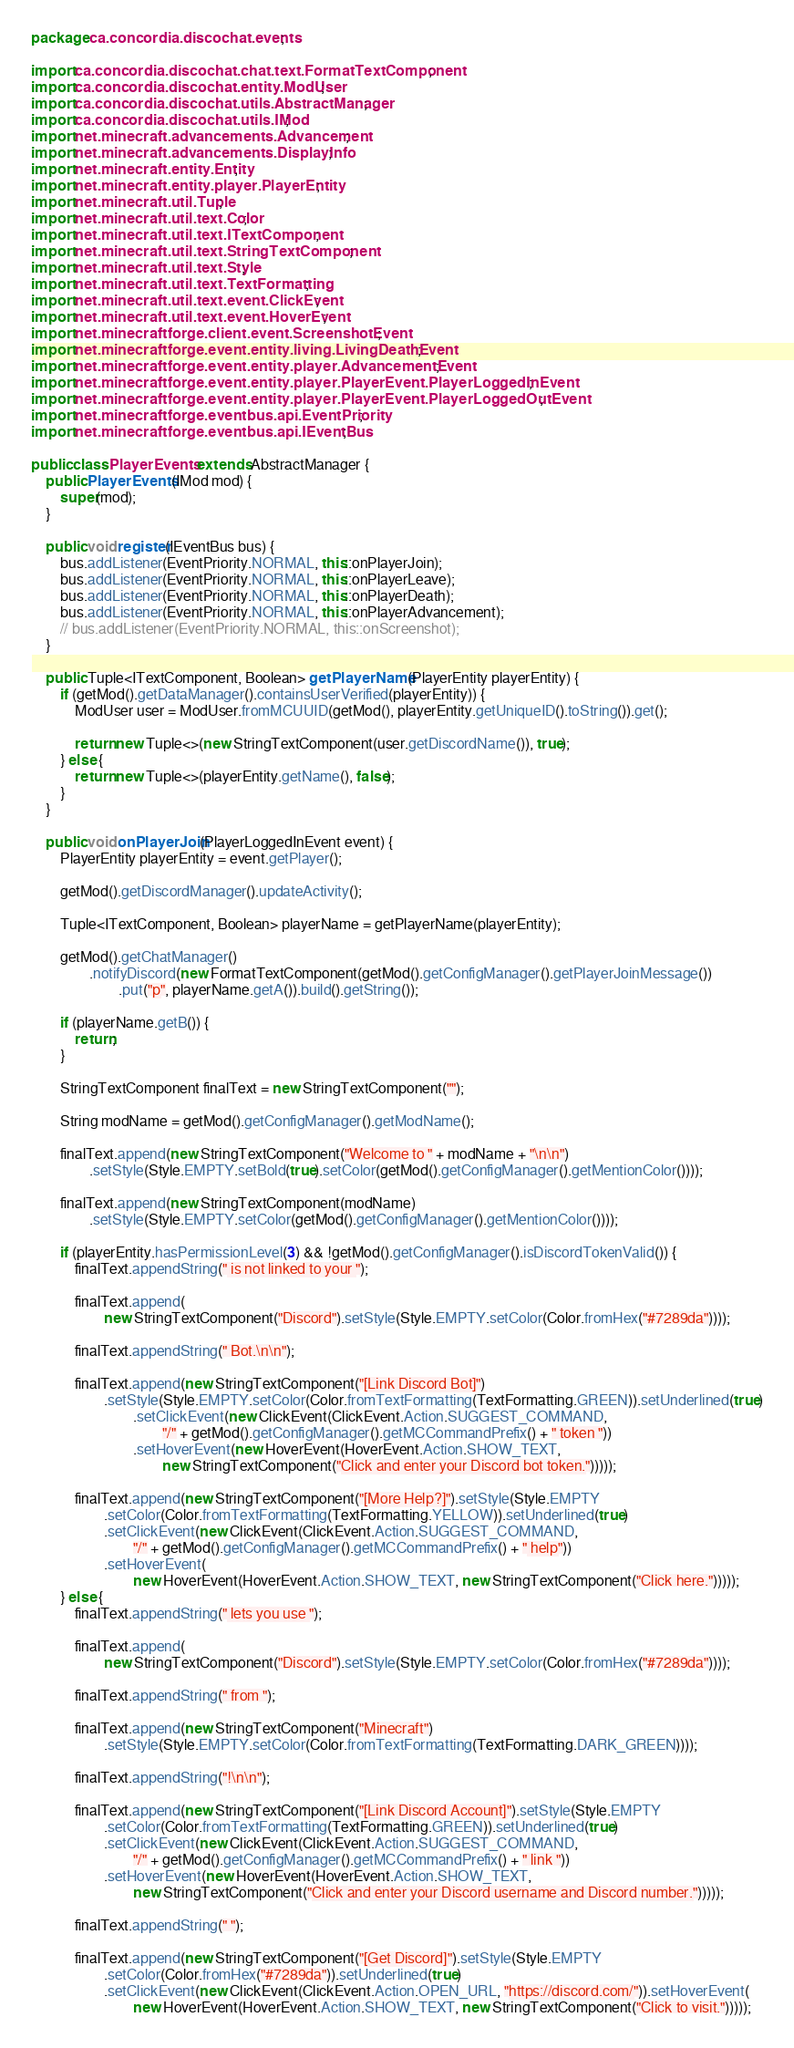<code> <loc_0><loc_0><loc_500><loc_500><_Java_>package ca.concordia.discochat.events;

import ca.concordia.discochat.chat.text.FormatTextComponent;
import ca.concordia.discochat.entity.ModUser;
import ca.concordia.discochat.utils.AbstractManager;
import ca.concordia.discochat.utils.IMod;
import net.minecraft.advancements.Advancement;
import net.minecraft.advancements.DisplayInfo;
import net.minecraft.entity.Entity;
import net.minecraft.entity.player.PlayerEntity;
import net.minecraft.util.Tuple;
import net.minecraft.util.text.Color;
import net.minecraft.util.text.ITextComponent;
import net.minecraft.util.text.StringTextComponent;
import net.minecraft.util.text.Style;
import net.minecraft.util.text.TextFormatting;
import net.minecraft.util.text.event.ClickEvent;
import net.minecraft.util.text.event.HoverEvent;
import net.minecraftforge.client.event.ScreenshotEvent;
import net.minecraftforge.event.entity.living.LivingDeathEvent;
import net.minecraftforge.event.entity.player.AdvancementEvent;
import net.minecraftforge.event.entity.player.PlayerEvent.PlayerLoggedInEvent;
import net.minecraftforge.event.entity.player.PlayerEvent.PlayerLoggedOutEvent;
import net.minecraftforge.eventbus.api.EventPriority;
import net.minecraftforge.eventbus.api.IEventBus;

public class PlayerEvents extends AbstractManager {
    public PlayerEvents(IMod mod) {
        super(mod);
    }

    public void register(IEventBus bus) {
        bus.addListener(EventPriority.NORMAL, this::onPlayerJoin);
        bus.addListener(EventPriority.NORMAL, this::onPlayerLeave);
        bus.addListener(EventPriority.NORMAL, this::onPlayerDeath);
        bus.addListener(EventPriority.NORMAL, this::onPlayerAdvancement);
        // bus.addListener(EventPriority.NORMAL, this::onScreenshot);
    }

    public Tuple<ITextComponent, Boolean> getPlayerName(PlayerEntity playerEntity) {
        if (getMod().getDataManager().containsUserVerified(playerEntity)) {
            ModUser user = ModUser.fromMCUUID(getMod(), playerEntity.getUniqueID().toString()).get();

            return new Tuple<>(new StringTextComponent(user.getDiscordName()), true);
        } else {
            return new Tuple<>(playerEntity.getName(), false);
        }
    }

    public void onPlayerJoin(PlayerLoggedInEvent event) {
        PlayerEntity playerEntity = event.getPlayer();

        getMod().getDiscordManager().updateActivity();

        Tuple<ITextComponent, Boolean> playerName = getPlayerName(playerEntity);

        getMod().getChatManager()
                .notifyDiscord(new FormatTextComponent(getMod().getConfigManager().getPlayerJoinMessage())
                        .put("p", playerName.getA()).build().getString());

        if (playerName.getB()) {
            return;
        }

        StringTextComponent finalText = new StringTextComponent("");

        String modName = getMod().getConfigManager().getModName();

        finalText.append(new StringTextComponent("Welcome to " + modName + "\n\n")
                .setStyle(Style.EMPTY.setBold(true).setColor(getMod().getConfigManager().getMentionColor())));

        finalText.append(new StringTextComponent(modName)
                .setStyle(Style.EMPTY.setColor(getMod().getConfigManager().getMentionColor())));

        if (playerEntity.hasPermissionLevel(3) && !getMod().getConfigManager().isDiscordTokenValid()) {
            finalText.appendString(" is not linked to your ");

            finalText.append(
                    new StringTextComponent("Discord").setStyle(Style.EMPTY.setColor(Color.fromHex("#7289da"))));

            finalText.appendString(" Bot.\n\n");

            finalText.append(new StringTextComponent("[Link Discord Bot]")
                    .setStyle(Style.EMPTY.setColor(Color.fromTextFormatting(TextFormatting.GREEN)).setUnderlined(true)
                            .setClickEvent(new ClickEvent(ClickEvent.Action.SUGGEST_COMMAND,
                                    "/" + getMod().getConfigManager().getMCCommandPrefix() + " token "))
                            .setHoverEvent(new HoverEvent(HoverEvent.Action.SHOW_TEXT,
                                    new StringTextComponent("Click and enter your Discord bot token.")))));

            finalText.append(new StringTextComponent("[More Help?]").setStyle(Style.EMPTY
                    .setColor(Color.fromTextFormatting(TextFormatting.YELLOW)).setUnderlined(true)
                    .setClickEvent(new ClickEvent(ClickEvent.Action.SUGGEST_COMMAND,
                            "/" + getMod().getConfigManager().getMCCommandPrefix() + " help"))
                    .setHoverEvent(
                            new HoverEvent(HoverEvent.Action.SHOW_TEXT, new StringTextComponent("Click here.")))));
        } else {
            finalText.appendString(" lets you use ");

            finalText.append(
                    new StringTextComponent("Discord").setStyle(Style.EMPTY.setColor(Color.fromHex("#7289da"))));

            finalText.appendString(" from ");

            finalText.append(new StringTextComponent("Minecraft")
                    .setStyle(Style.EMPTY.setColor(Color.fromTextFormatting(TextFormatting.DARK_GREEN))));

            finalText.appendString("!\n\n");

            finalText.append(new StringTextComponent("[Link Discord Account]").setStyle(Style.EMPTY
                    .setColor(Color.fromTextFormatting(TextFormatting.GREEN)).setUnderlined(true)
                    .setClickEvent(new ClickEvent(ClickEvent.Action.SUGGEST_COMMAND,
                            "/" + getMod().getConfigManager().getMCCommandPrefix() + " link "))
                    .setHoverEvent(new HoverEvent(HoverEvent.Action.SHOW_TEXT,
                            new StringTextComponent("Click and enter your Discord username and Discord number.")))));

            finalText.appendString(" ");

            finalText.append(new StringTextComponent("[Get Discord]").setStyle(Style.EMPTY
                    .setColor(Color.fromHex("#7289da")).setUnderlined(true)
                    .setClickEvent(new ClickEvent(ClickEvent.Action.OPEN_URL, "https://discord.com/")).setHoverEvent(
                            new HoverEvent(HoverEvent.Action.SHOW_TEXT, new StringTextComponent("Click to visit.")))));
</code> 